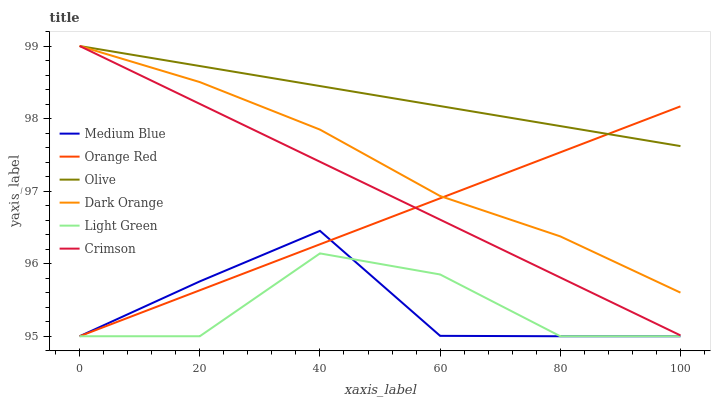Does Light Green have the minimum area under the curve?
Answer yes or no. Yes. Does Olive have the maximum area under the curve?
Answer yes or no. Yes. Does Medium Blue have the minimum area under the curve?
Answer yes or no. No. Does Medium Blue have the maximum area under the curve?
Answer yes or no. No. Is Olive the smoothest?
Answer yes or no. Yes. Is Light Green the roughest?
Answer yes or no. Yes. Is Medium Blue the smoothest?
Answer yes or no. No. Is Medium Blue the roughest?
Answer yes or no. No. Does Medium Blue have the lowest value?
Answer yes or no. Yes. Does Crimson have the lowest value?
Answer yes or no. No. Does Olive have the highest value?
Answer yes or no. Yes. Does Medium Blue have the highest value?
Answer yes or no. No. Is Medium Blue less than Olive?
Answer yes or no. Yes. Is Crimson greater than Medium Blue?
Answer yes or no. Yes. Does Light Green intersect Medium Blue?
Answer yes or no. Yes. Is Light Green less than Medium Blue?
Answer yes or no. No. Is Light Green greater than Medium Blue?
Answer yes or no. No. Does Medium Blue intersect Olive?
Answer yes or no. No. 